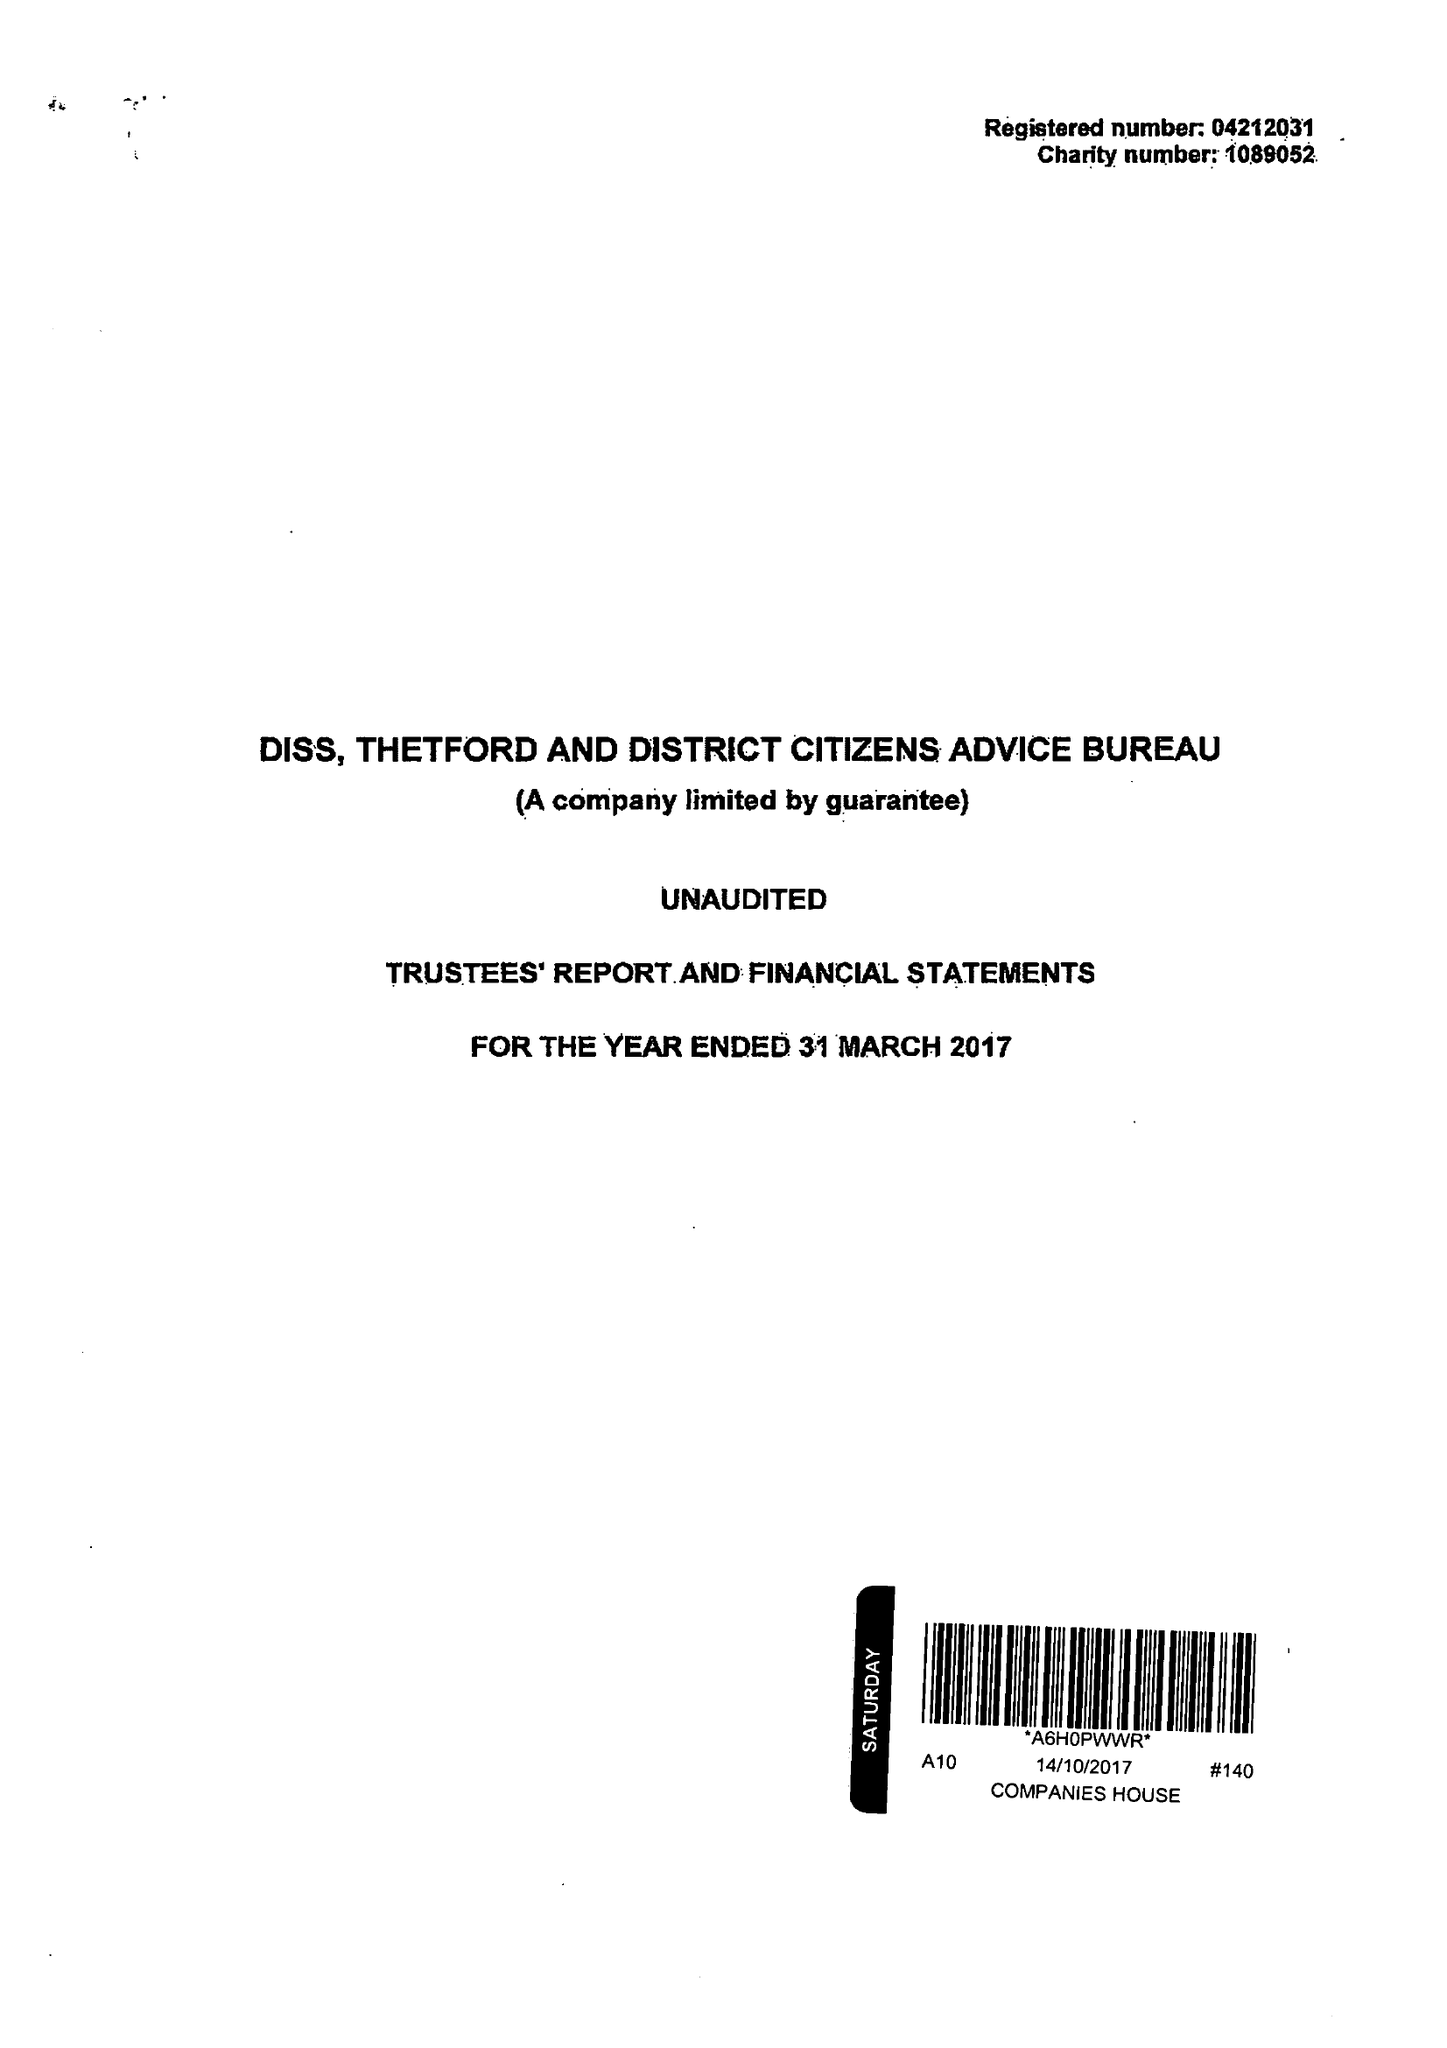What is the value for the address__post_town?
Answer the question using a single word or phrase. DISS 